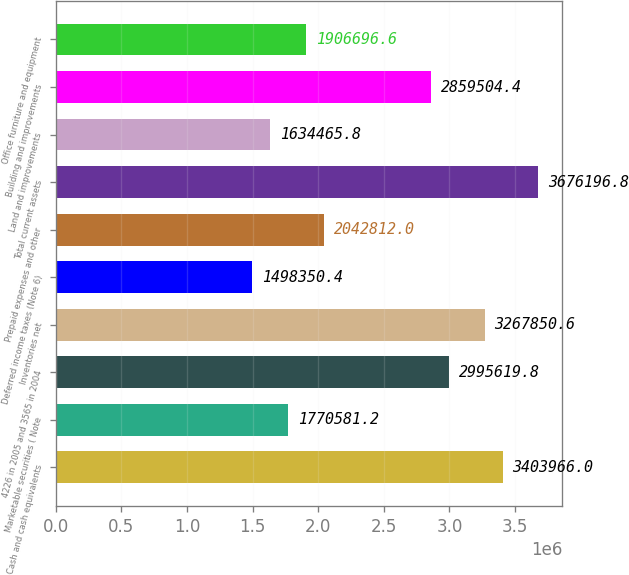Convert chart to OTSL. <chart><loc_0><loc_0><loc_500><loc_500><bar_chart><fcel>Cash and cash equivalents<fcel>Marketable securities ( Note<fcel>4226 in 2005 and 3565 in 2004<fcel>Inventories net<fcel>Deferred income taxes (Note 6)<fcel>Prepaid expenses and other<fcel>Total current assets<fcel>Land and improvements<fcel>Building and improvements<fcel>Office furniture and equipment<nl><fcel>3.40397e+06<fcel>1.77058e+06<fcel>2.99562e+06<fcel>3.26785e+06<fcel>1.49835e+06<fcel>2.04281e+06<fcel>3.6762e+06<fcel>1.63447e+06<fcel>2.8595e+06<fcel>1.9067e+06<nl></chart> 